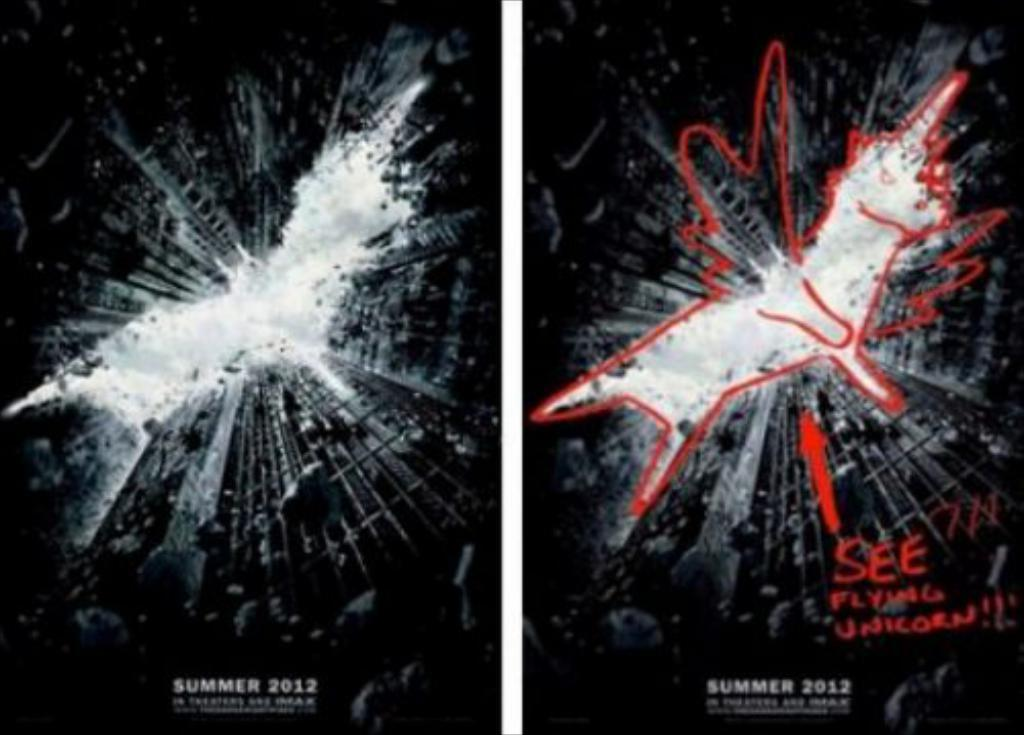<image>
Provide a brief description of the given image. Two "flying unicorns"  posters say summer 2012 